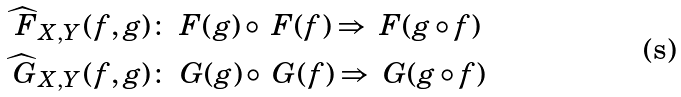<formula> <loc_0><loc_0><loc_500><loc_500>\widehat { \ F } _ { X , Y } ( f , g ) & \colon \ F ( g ) \circ \ F ( f ) \Rightarrow \ F ( g \circ f ) \\ \widehat { \ G } _ { X , Y } ( f , g ) & \colon \ G ( g ) \circ \ G ( f ) \Rightarrow \ G ( g \circ f )</formula> 